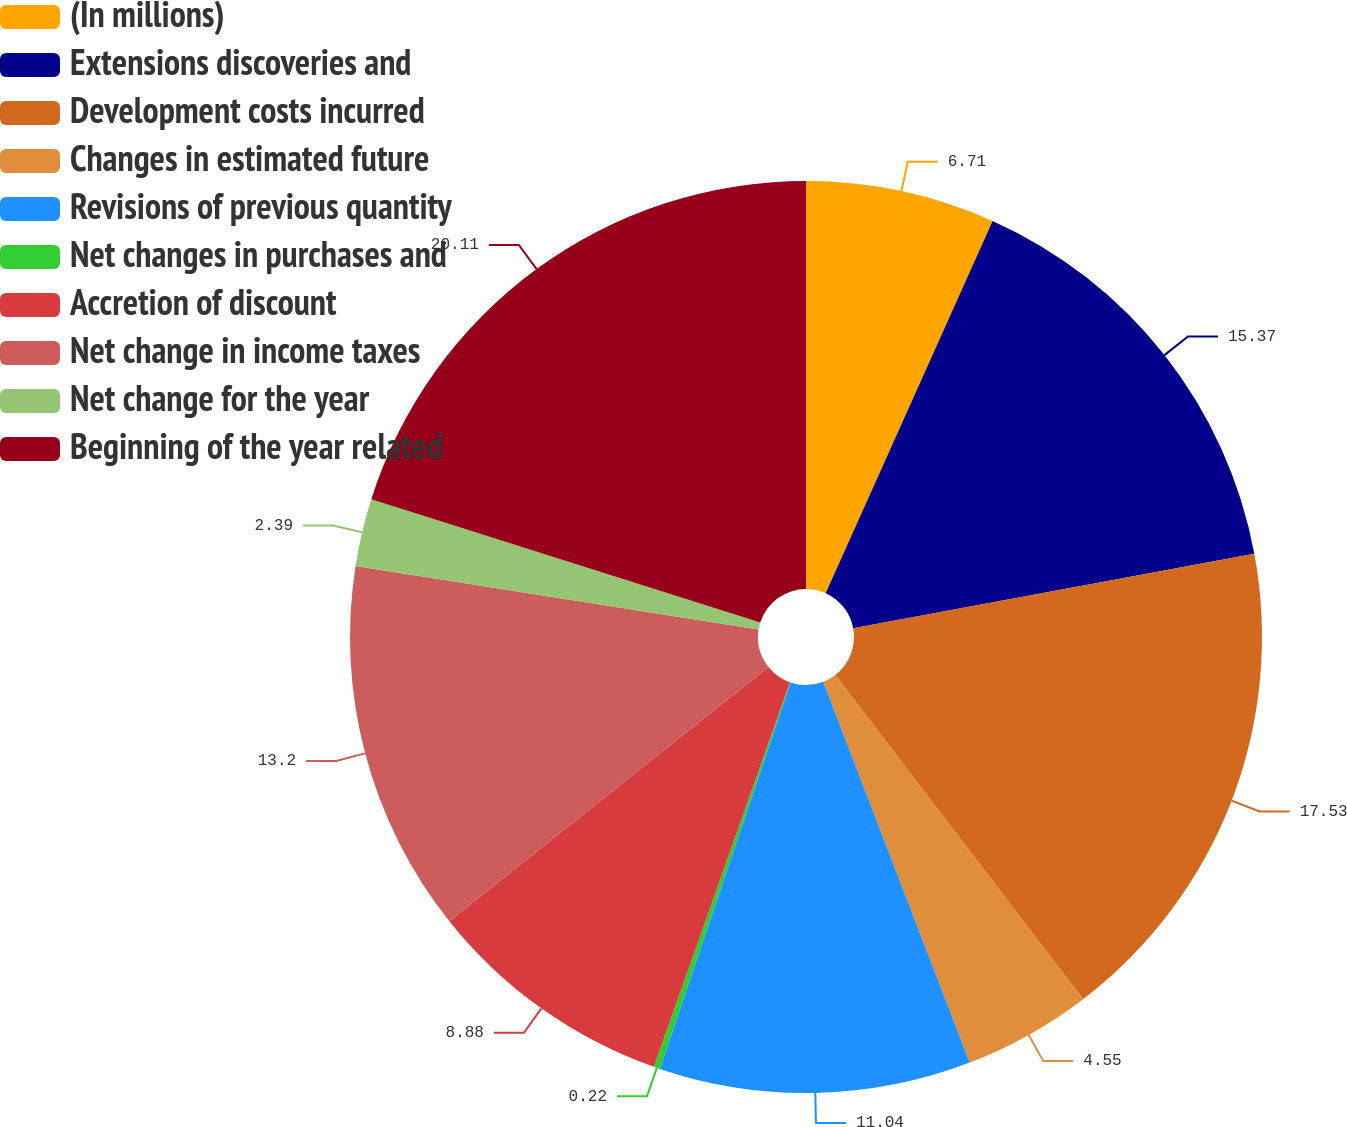Convert chart. <chart><loc_0><loc_0><loc_500><loc_500><pie_chart><fcel>(In millions)<fcel>Extensions discoveries and<fcel>Development costs incurred<fcel>Changes in estimated future<fcel>Revisions of previous quantity<fcel>Net changes in purchases and<fcel>Accretion of discount<fcel>Net change in income taxes<fcel>Net change for the year<fcel>Beginning of the year related<nl><fcel>6.71%<fcel>15.37%<fcel>17.53%<fcel>4.55%<fcel>11.04%<fcel>0.22%<fcel>8.88%<fcel>13.2%<fcel>2.39%<fcel>20.12%<nl></chart> 